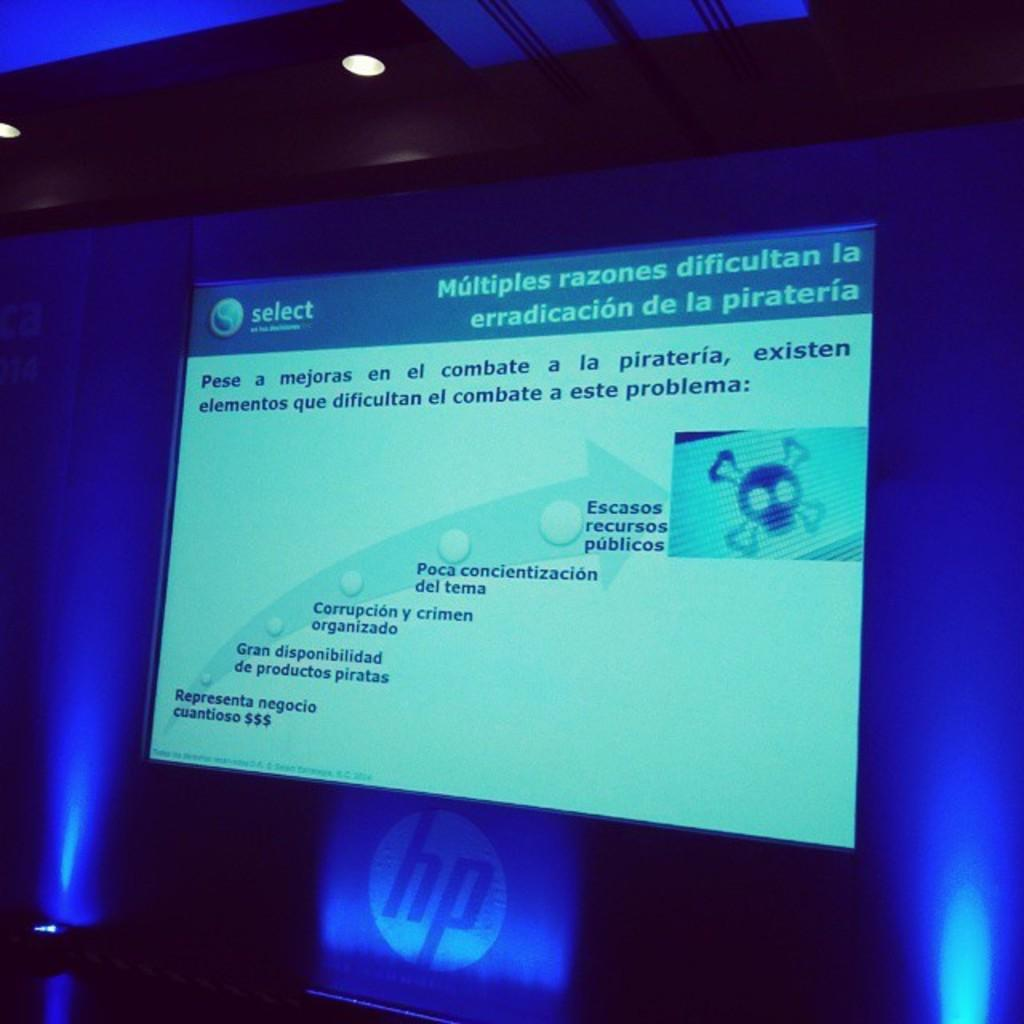<image>
Give a short and clear explanation of the subsequent image. A large screen has the word select in the left corner. 